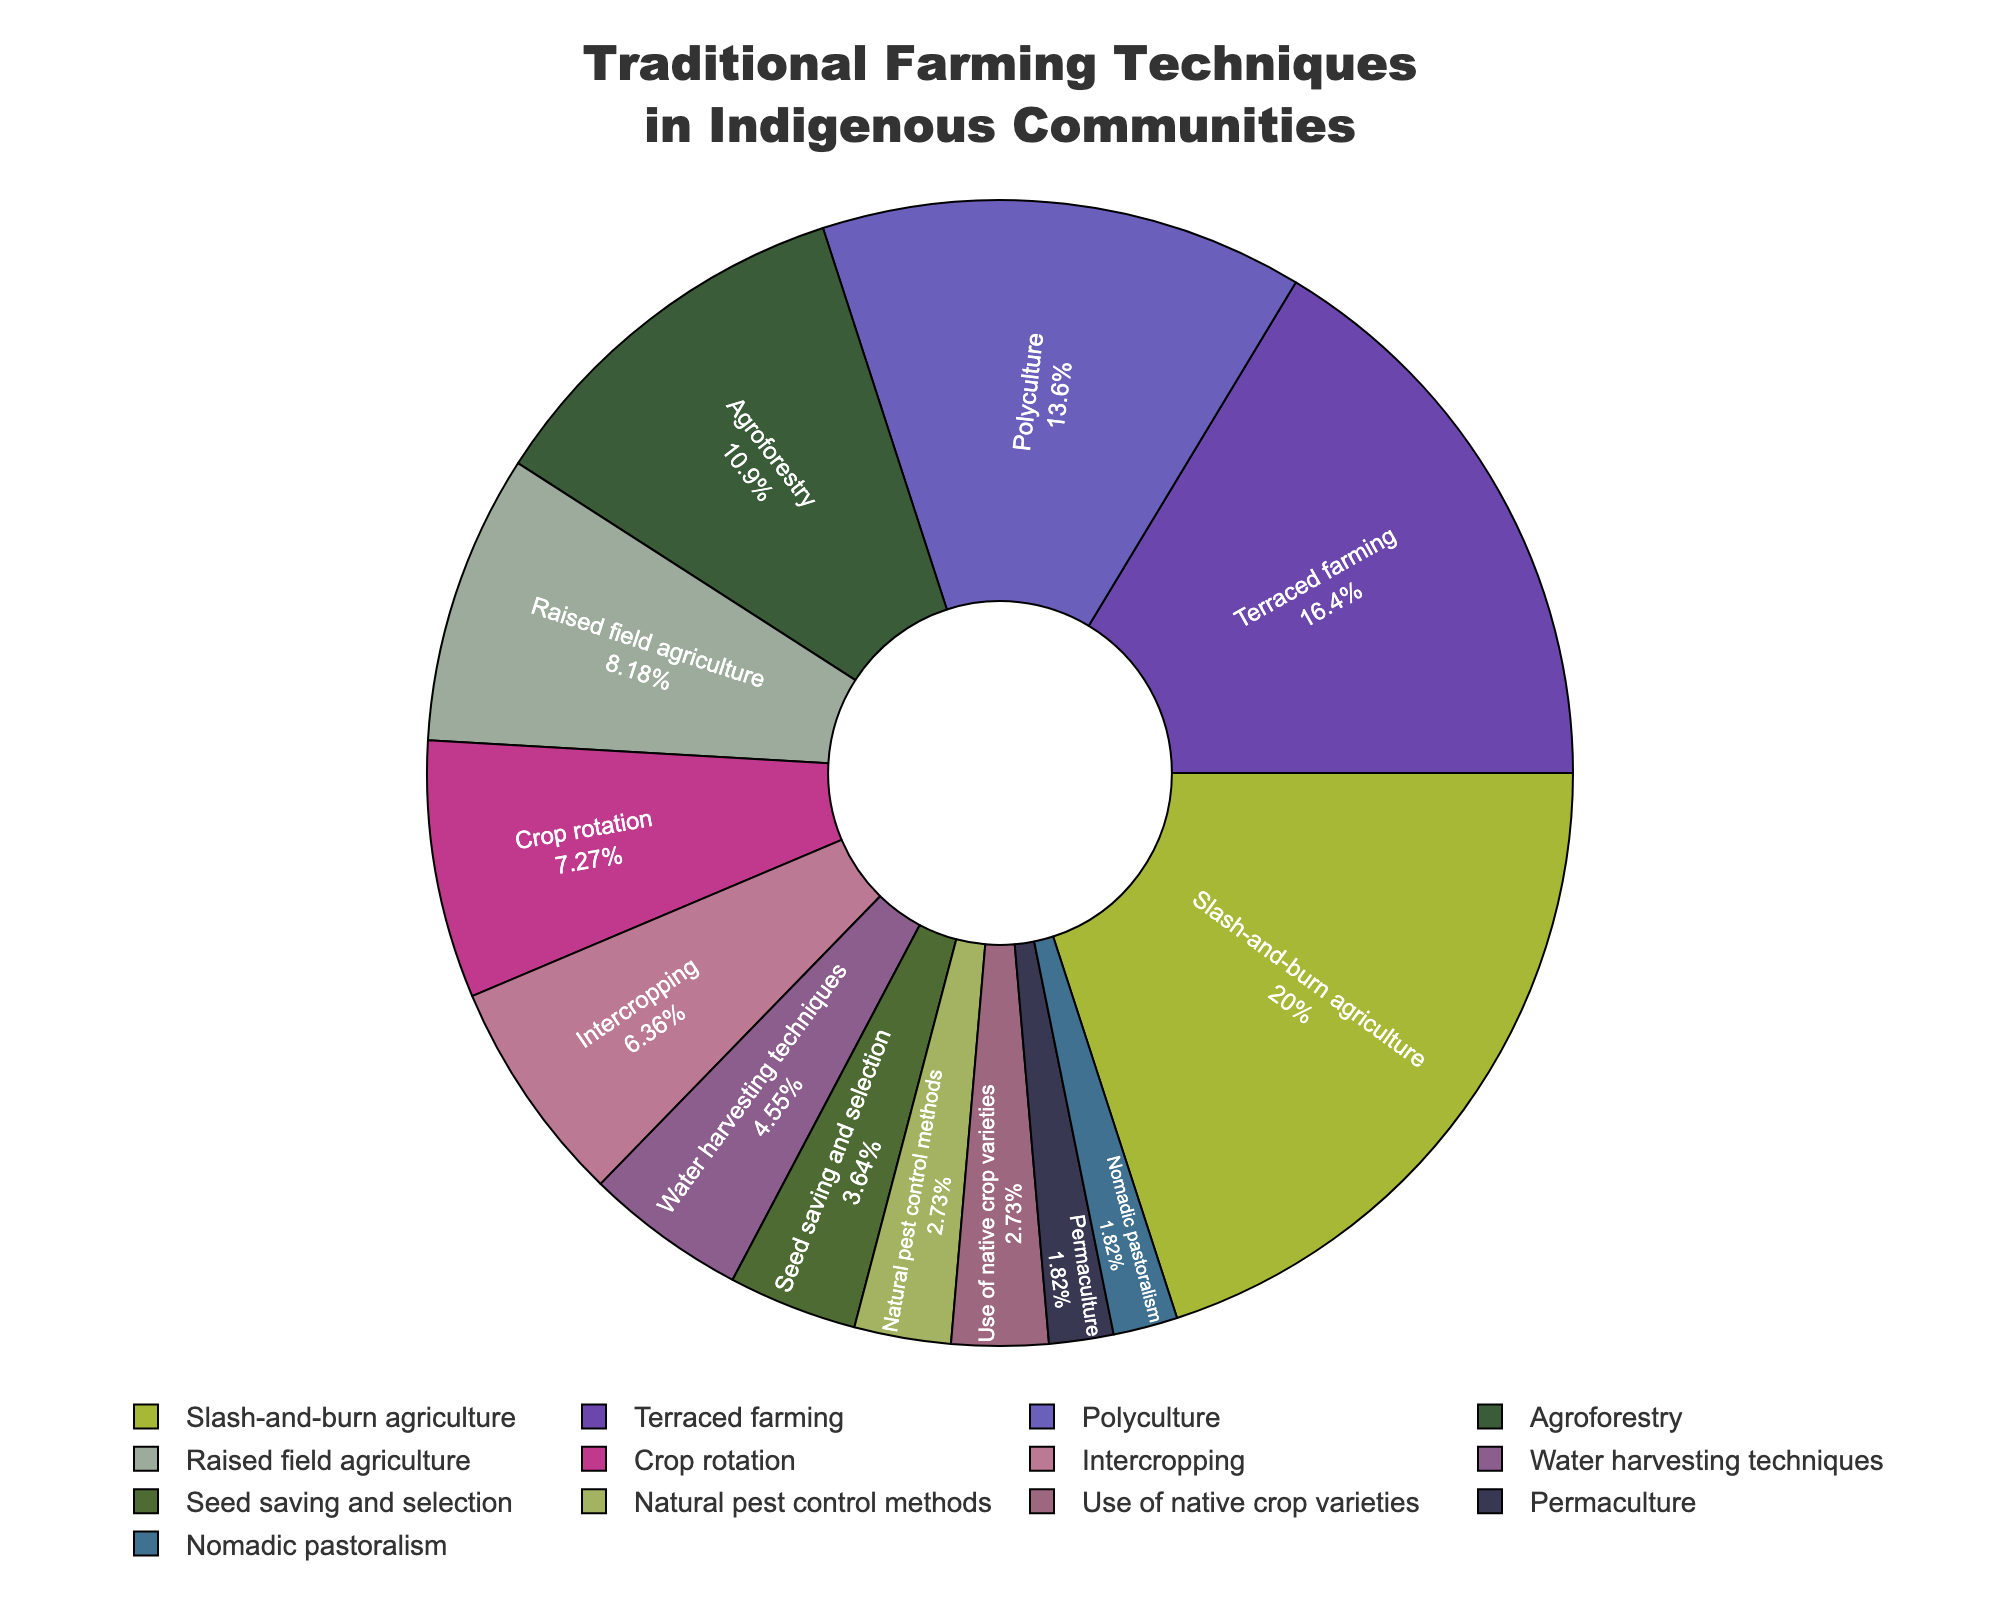What's the most common traditional farming technique among indigenous communities? The most common technique is indicated by the largest section of the pie chart. The largest section is "Slash-and-burn agriculture" which makes up 22% of the chart.
Answer: Slash-and-burn agriculture How much more common is slash-and-burn agriculture compared to permaculture? "Slash-and-burn agriculture" is 22% and "Permaculture" is 2%. The difference is 22% - 2% = 20%.
Answer: 20% Which two techniques together constitute one-third of the total techniques used? "Slash-and-burn agriculture" (22%) and "Terraced farming" (18%) are the top two slices. Together, they add up to 22% + 18% = 40%, which is more than one-third. The next largest slices are "Polyculture" (15%) and "Agroforestry" (12%), totaling 15% + 12% = 27%, which is less than one-third. Hence, permaculture (2%) can be added to polyculture and agroforestry to exactly fit one-third. So, the answer is "Polyculture" 15% + "Agroforestry" 12% + "Permaculture" 2% = 29%.
Answer: Polyculture and Agroforestry and Permaculture What percentage of the techniques involves multiple crop species? Techniques involving multiple crop species include "Polyculture" (15%), "Agroforestry" (12%), "Crop rotation" (8%), "Intercropping" (7%). Summing these up gives 15% + 12% + 8% + 7% = 42%.
Answer: 42% Are there any techniques equally represented in the chart? The techniques represented equally, 3%, are "Natural pest control methods" and "Use of native crop varieties".
Answer: Yes, Natural pest control methods and Use of native crop varieties How much larger is the section for terraced farming compared to raised field agriculture? "Terraced farming" is 18% and "Raised field agriculture" is 9%. The difference is 18% - 9% = 9%.
Answer: 9% Compare agroforestry and crop rotation in terms of their usage percentage. "Agroforestry" is 12% and "Crop rotation" is 8%. Agroforestry is more used by 12% - 8% = 4%.
Answer: Agroforestry is more used by 4% What is the combined percentage of the least common techniques? The least common techniques are "Permaculture" (2%) and "Nomadic pastoralism" (2%). Combined, they make up 2% + 2% = 4%.
Answer: 4% What is the total percentage for techniques related to water and soil management? Techniques related to water and soil management include "Terraced farming" (18%), "Water harvesting techniques" (5%), and "Raised field agriculture" (9%). Summing these up gives 18% + 5% + 9% = 32%.
Answer: 32% Which technique has the smallest representation, and what is its percentage? Both "Permaculture" and "Nomadic pastoralism" are the least represented at 2% each.
Answer: Permaculture and Nomadic pastoralism, 2% 